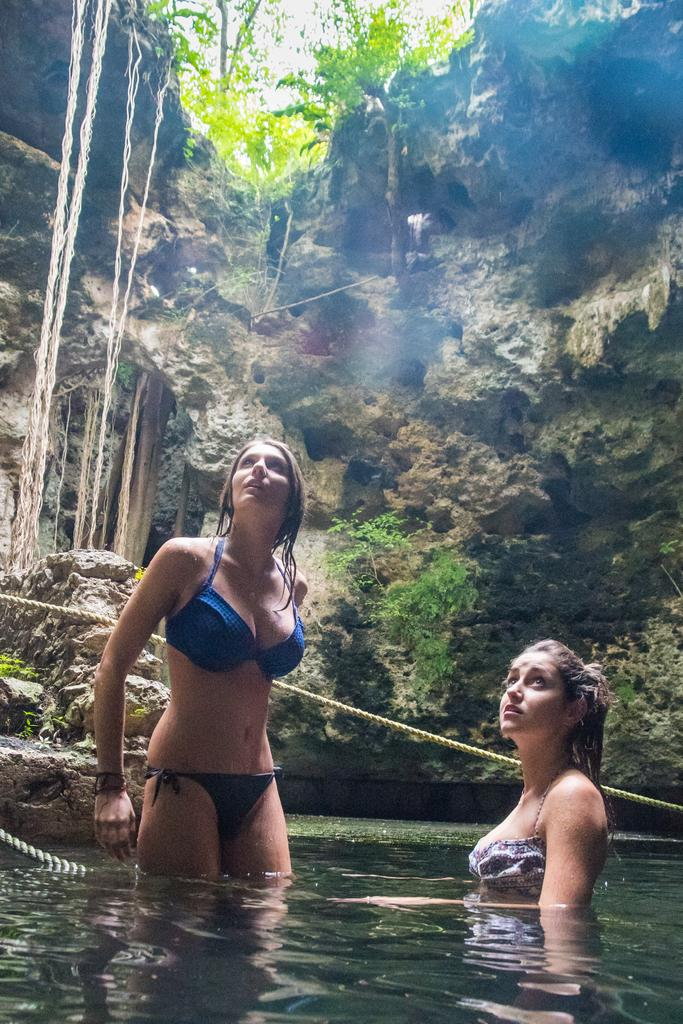How many women are in the water in the image? There are two women in the water in the image. What else can be seen in the image besides the women? Ropes are visible in the image. What can be seen in the background of the image? There are rocks and trees in the background of the image. What type of treatment are the babies receiving in the image? There are no babies present in the image, so it is not possible to determine what type of treatment they might be receiving. 